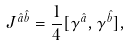Convert formula to latex. <formula><loc_0><loc_0><loc_500><loc_500>J ^ { \hat { a } \hat { b } } = \frac { 1 } { 4 } [ \gamma ^ { \hat { a } } , \gamma ^ { \hat { b } } ] ,</formula> 